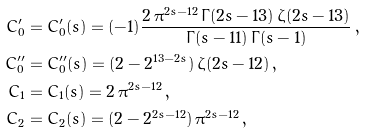Convert formula to latex. <formula><loc_0><loc_0><loc_500><loc_500>C _ { 0 } ^ { \prime } & = C _ { 0 } ^ { \prime } ( s ) = ( - 1 ) \frac { 2 \, \pi ^ { 2 s - 1 2 } \, \Gamma ( 2 s - 1 3 ) \, \zeta ( 2 s - 1 3 ) } { \Gamma ( s - 1 1 ) \, \Gamma ( s - 1 ) } \, , \\ C _ { 0 } ^ { \prime \prime } & = C _ { 0 } ^ { \prime \prime } ( s ) = ( 2 - 2 ^ { 1 3 - 2 s } ) \, \zeta ( 2 s - 1 2 ) \, , \\ C _ { 1 } & = C _ { 1 } ( s ) = 2 \, \pi ^ { 2 s - 1 2 } \, , \\ C _ { 2 } & = C _ { 2 } ( s ) = ( 2 - 2 ^ { 2 s - 1 2 } ) \, \pi ^ { 2 s - 1 2 } \, ,</formula> 